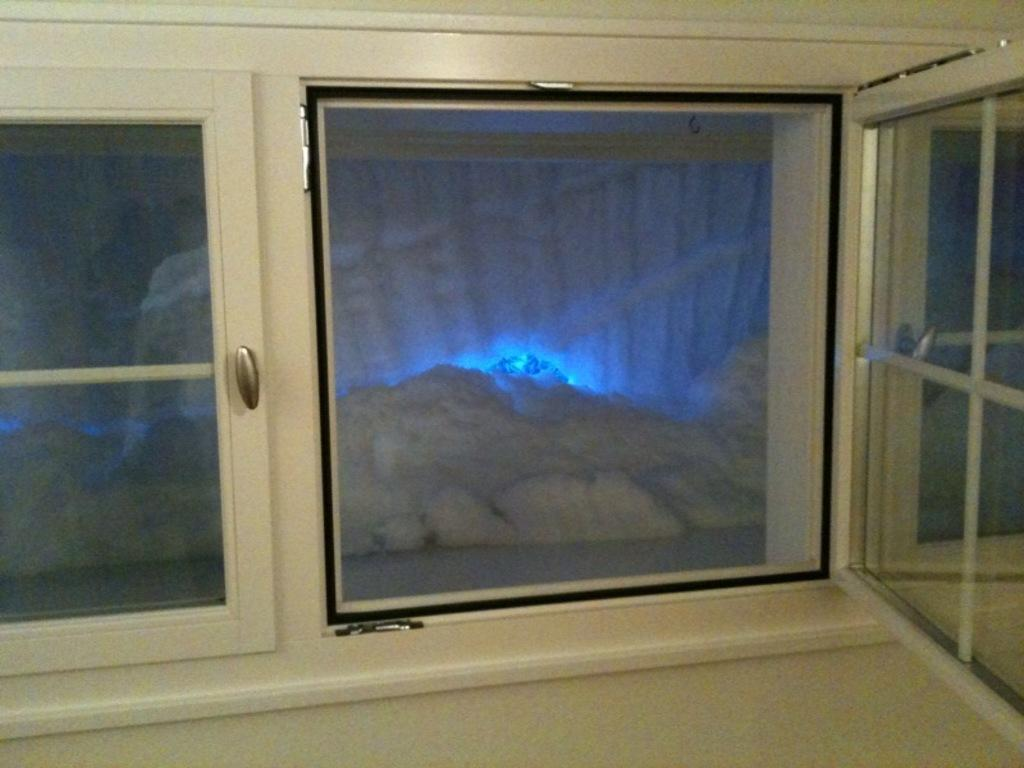What type of surface is visible in the image? There is a floor in the image. What architectural feature allows light and air into the space? There is a window in the image. What can be used to enter or exit the space? There are doors in the image. What type of tank is visible in the image? There is no tank present in the image. Where is the lunchroom located in the image? The provided facts do not mention a lunchroom, so its location cannot be determined from the image. 